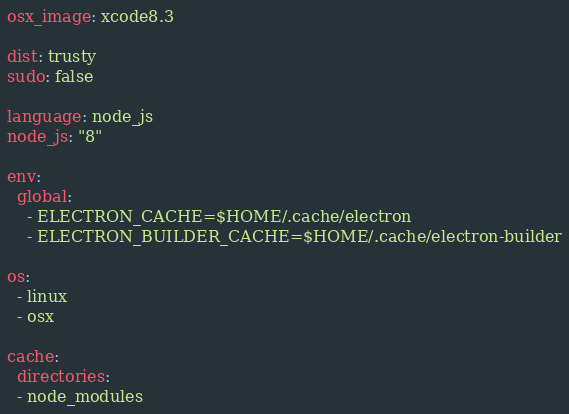Convert code to text. <code><loc_0><loc_0><loc_500><loc_500><_YAML_>osx_image: xcode8.3

dist: trusty
sudo: false

language: node_js
node_js: "8"

env:
  global:
    - ELECTRON_CACHE=$HOME/.cache/electron
    - ELECTRON_BUILDER_CACHE=$HOME/.cache/electron-builder

os:
  - linux
  - osx

cache:
  directories:
  - node_modules</code> 